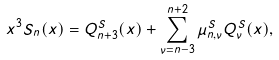Convert formula to latex. <formula><loc_0><loc_0><loc_500><loc_500>x ^ { 3 } S _ { n } ( x ) = Q ^ { S } _ { n + 3 } ( x ) + \sum _ { \nu = n - 3 } ^ { n + 2 } \mu ^ { S } _ { n , \nu } Q ^ { S } _ { \nu } ( x ) ,</formula> 